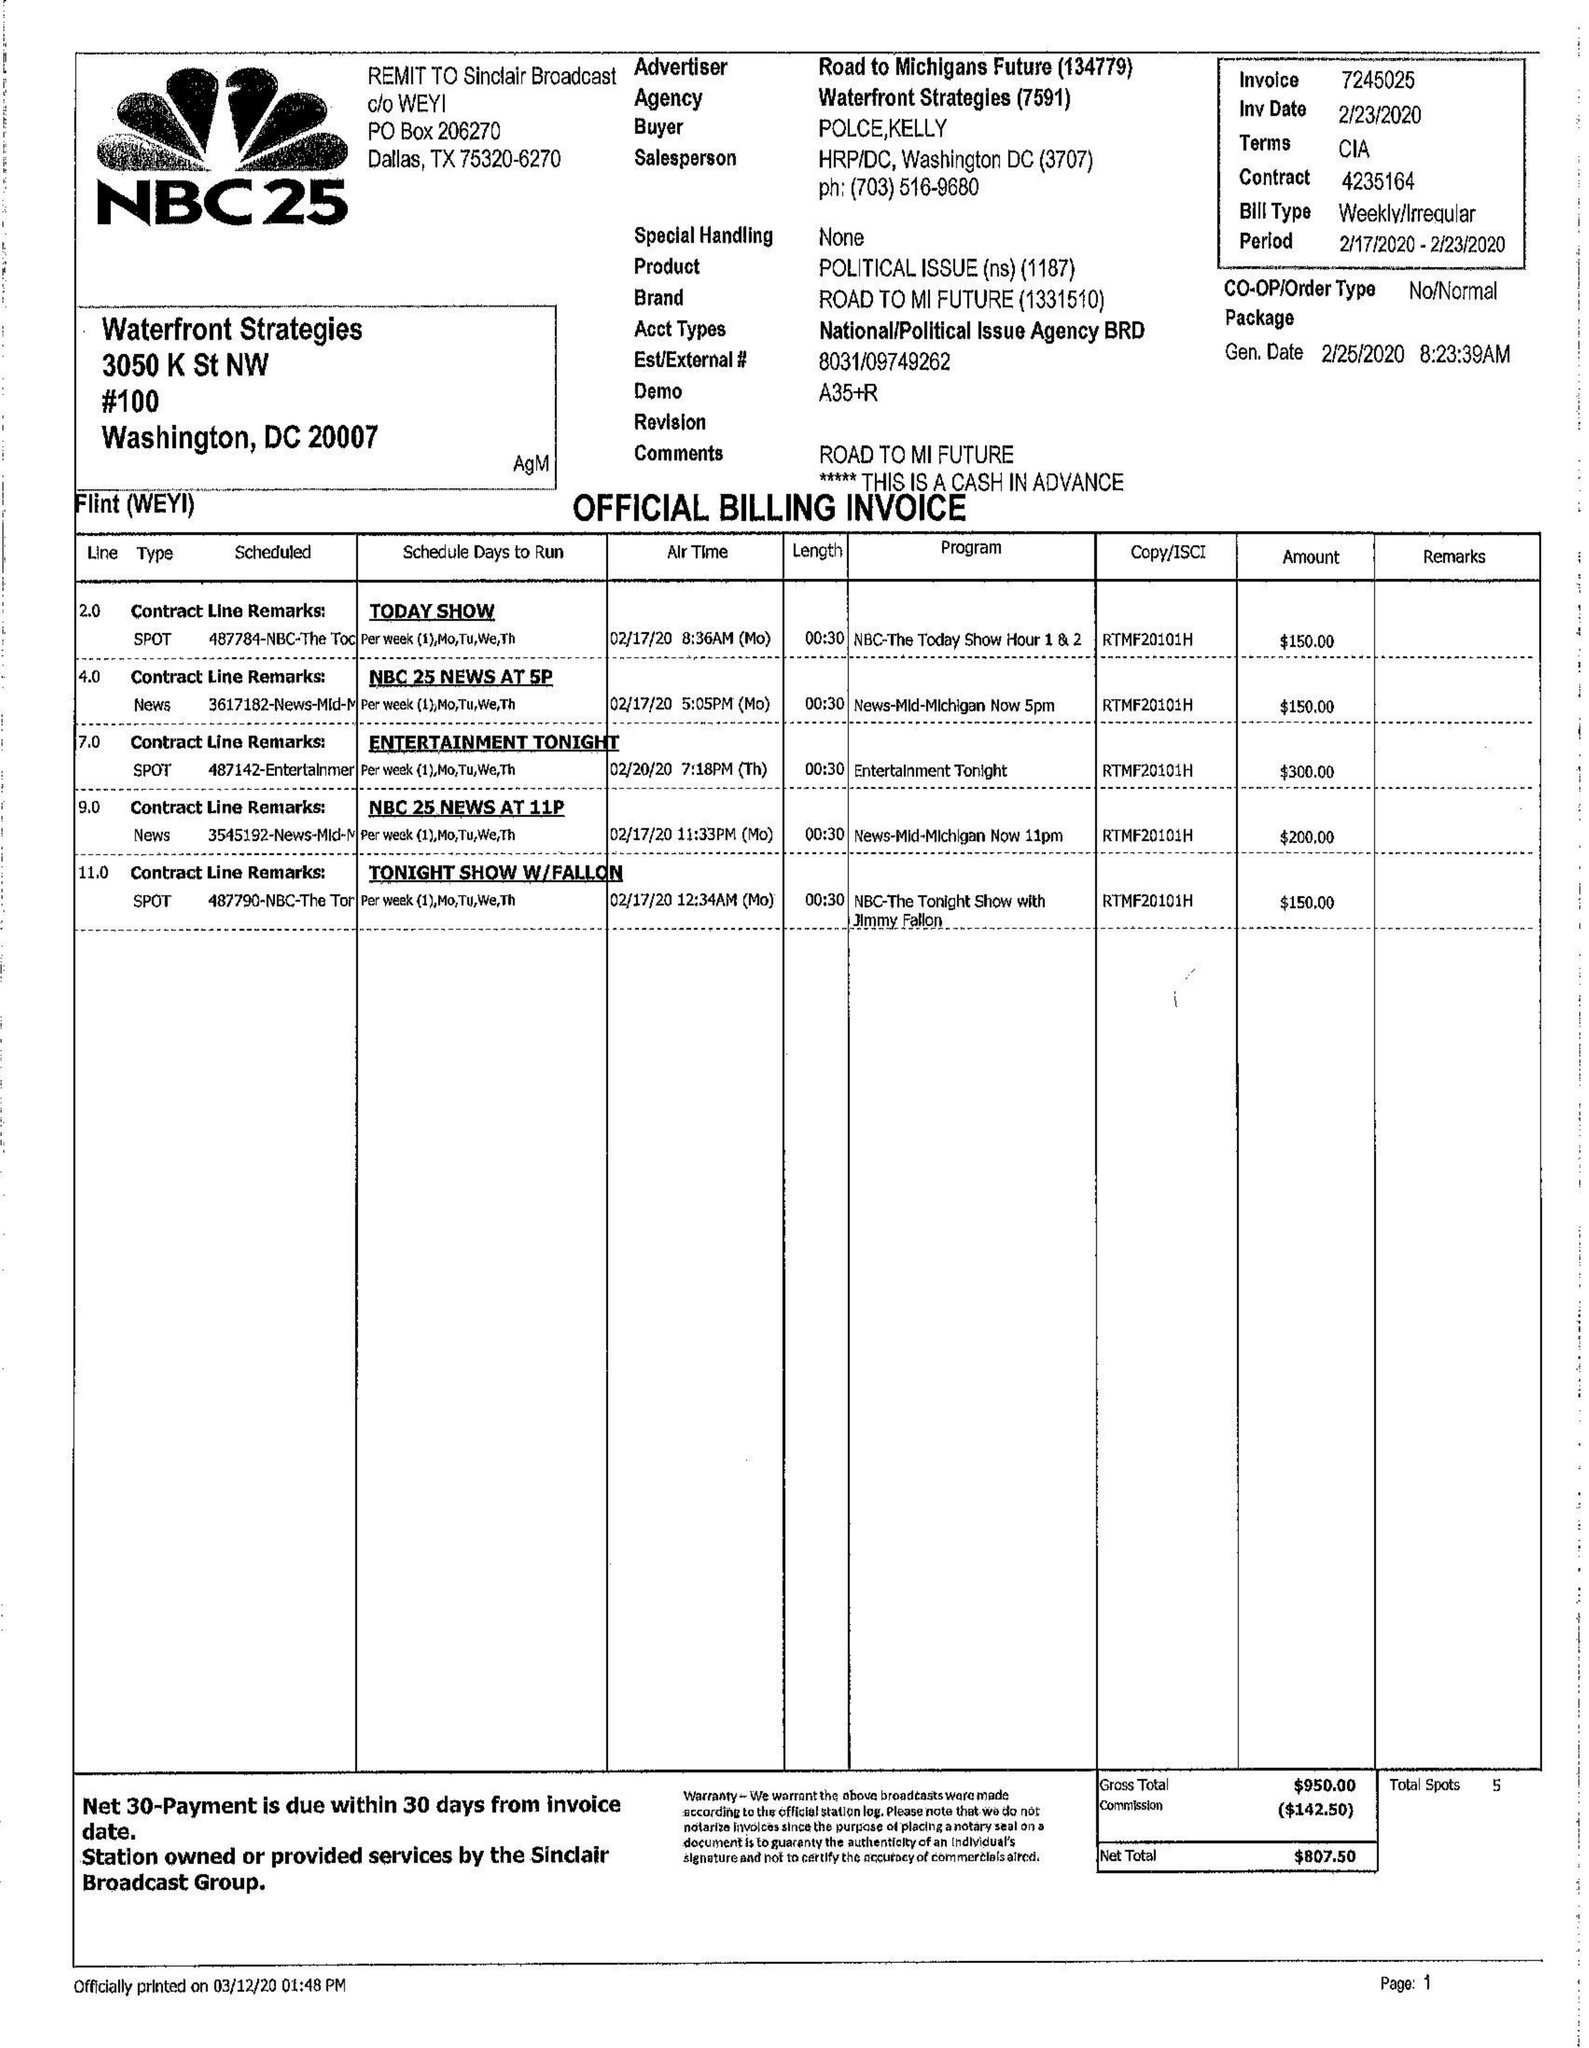What is the value for the flight_from?
Answer the question using a single word or phrase. 02/17/20 